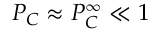Convert formula to latex. <formula><loc_0><loc_0><loc_500><loc_500>P _ { C } \approx P _ { C } ^ { \infty } \ll 1</formula> 